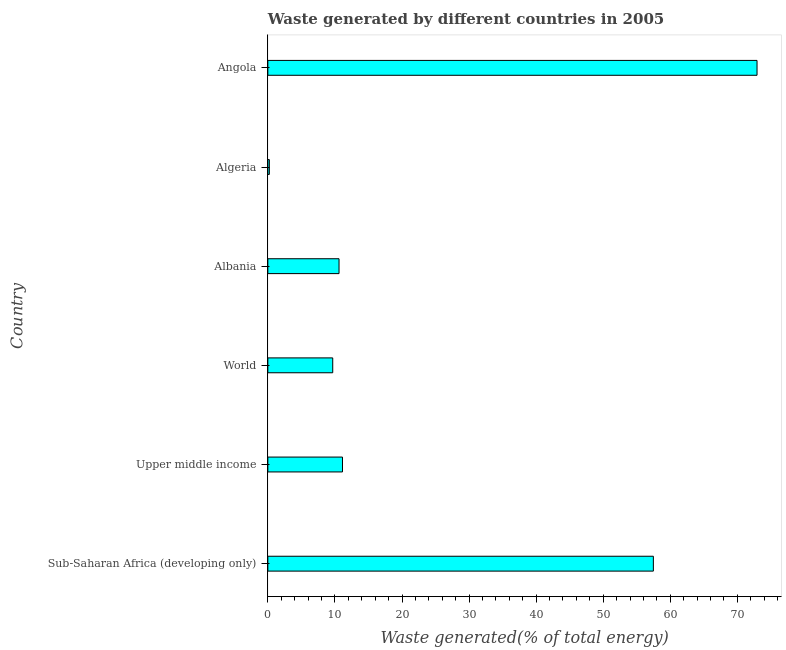Does the graph contain grids?
Offer a very short reply. No. What is the title of the graph?
Your response must be concise. Waste generated by different countries in 2005. What is the label or title of the X-axis?
Keep it short and to the point. Waste generated(% of total energy). What is the label or title of the Y-axis?
Ensure brevity in your answer.  Country. What is the amount of waste generated in Angola?
Give a very brief answer. 72.93. Across all countries, what is the maximum amount of waste generated?
Your answer should be very brief. 72.93. Across all countries, what is the minimum amount of waste generated?
Your response must be concise. 0.22. In which country was the amount of waste generated maximum?
Your answer should be compact. Angola. In which country was the amount of waste generated minimum?
Offer a very short reply. Algeria. What is the sum of the amount of waste generated?
Ensure brevity in your answer.  162.03. What is the difference between the amount of waste generated in Algeria and Angola?
Make the answer very short. -72.71. What is the average amount of waste generated per country?
Keep it short and to the point. 27.01. What is the median amount of waste generated?
Your answer should be compact. 10.87. In how many countries, is the amount of waste generated greater than 58 %?
Your answer should be very brief. 1. What is the ratio of the amount of waste generated in Angola to that in Upper middle income?
Offer a terse response. 6.55. Is the amount of waste generated in Angola less than that in World?
Keep it short and to the point. No. What is the difference between the highest and the second highest amount of waste generated?
Your response must be concise. 15.46. What is the difference between the highest and the lowest amount of waste generated?
Ensure brevity in your answer.  72.71. Are all the bars in the graph horizontal?
Your response must be concise. Yes. Are the values on the major ticks of X-axis written in scientific E-notation?
Your response must be concise. No. What is the Waste generated(% of total energy) in Sub-Saharan Africa (developing only)?
Offer a terse response. 57.47. What is the Waste generated(% of total energy) of Upper middle income?
Give a very brief answer. 11.13. What is the Waste generated(% of total energy) of World?
Give a very brief answer. 9.67. What is the Waste generated(% of total energy) of Albania?
Your answer should be very brief. 10.61. What is the Waste generated(% of total energy) of Algeria?
Your answer should be compact. 0.22. What is the Waste generated(% of total energy) in Angola?
Keep it short and to the point. 72.93. What is the difference between the Waste generated(% of total energy) in Sub-Saharan Africa (developing only) and Upper middle income?
Give a very brief answer. 46.34. What is the difference between the Waste generated(% of total energy) in Sub-Saharan Africa (developing only) and World?
Provide a short and direct response. 47.8. What is the difference between the Waste generated(% of total energy) in Sub-Saharan Africa (developing only) and Albania?
Offer a very short reply. 46.86. What is the difference between the Waste generated(% of total energy) in Sub-Saharan Africa (developing only) and Algeria?
Your response must be concise. 57.25. What is the difference between the Waste generated(% of total energy) in Sub-Saharan Africa (developing only) and Angola?
Keep it short and to the point. -15.46. What is the difference between the Waste generated(% of total energy) in Upper middle income and World?
Provide a succinct answer. 1.45. What is the difference between the Waste generated(% of total energy) in Upper middle income and Albania?
Give a very brief answer. 0.52. What is the difference between the Waste generated(% of total energy) in Upper middle income and Algeria?
Make the answer very short. 10.91. What is the difference between the Waste generated(% of total energy) in Upper middle income and Angola?
Offer a terse response. -61.8. What is the difference between the Waste generated(% of total energy) in World and Albania?
Keep it short and to the point. -0.94. What is the difference between the Waste generated(% of total energy) in World and Algeria?
Give a very brief answer. 9.45. What is the difference between the Waste generated(% of total energy) in World and Angola?
Provide a short and direct response. -63.25. What is the difference between the Waste generated(% of total energy) in Albania and Algeria?
Your response must be concise. 10.39. What is the difference between the Waste generated(% of total energy) in Albania and Angola?
Provide a succinct answer. -62.32. What is the difference between the Waste generated(% of total energy) in Algeria and Angola?
Your response must be concise. -72.71. What is the ratio of the Waste generated(% of total energy) in Sub-Saharan Africa (developing only) to that in Upper middle income?
Make the answer very short. 5.17. What is the ratio of the Waste generated(% of total energy) in Sub-Saharan Africa (developing only) to that in World?
Your answer should be compact. 5.94. What is the ratio of the Waste generated(% of total energy) in Sub-Saharan Africa (developing only) to that in Albania?
Keep it short and to the point. 5.42. What is the ratio of the Waste generated(% of total energy) in Sub-Saharan Africa (developing only) to that in Algeria?
Provide a succinct answer. 260.26. What is the ratio of the Waste generated(% of total energy) in Sub-Saharan Africa (developing only) to that in Angola?
Make the answer very short. 0.79. What is the ratio of the Waste generated(% of total energy) in Upper middle income to that in World?
Offer a terse response. 1.15. What is the ratio of the Waste generated(% of total energy) in Upper middle income to that in Albania?
Offer a very short reply. 1.05. What is the ratio of the Waste generated(% of total energy) in Upper middle income to that in Algeria?
Your answer should be very brief. 50.39. What is the ratio of the Waste generated(% of total energy) in Upper middle income to that in Angola?
Your answer should be compact. 0.15. What is the ratio of the Waste generated(% of total energy) in World to that in Albania?
Make the answer very short. 0.91. What is the ratio of the Waste generated(% of total energy) in World to that in Algeria?
Your response must be concise. 43.81. What is the ratio of the Waste generated(% of total energy) in World to that in Angola?
Give a very brief answer. 0.13. What is the ratio of the Waste generated(% of total energy) in Albania to that in Algeria?
Your response must be concise. 48.06. What is the ratio of the Waste generated(% of total energy) in Albania to that in Angola?
Your answer should be very brief. 0.15. What is the ratio of the Waste generated(% of total energy) in Algeria to that in Angola?
Provide a succinct answer. 0. 